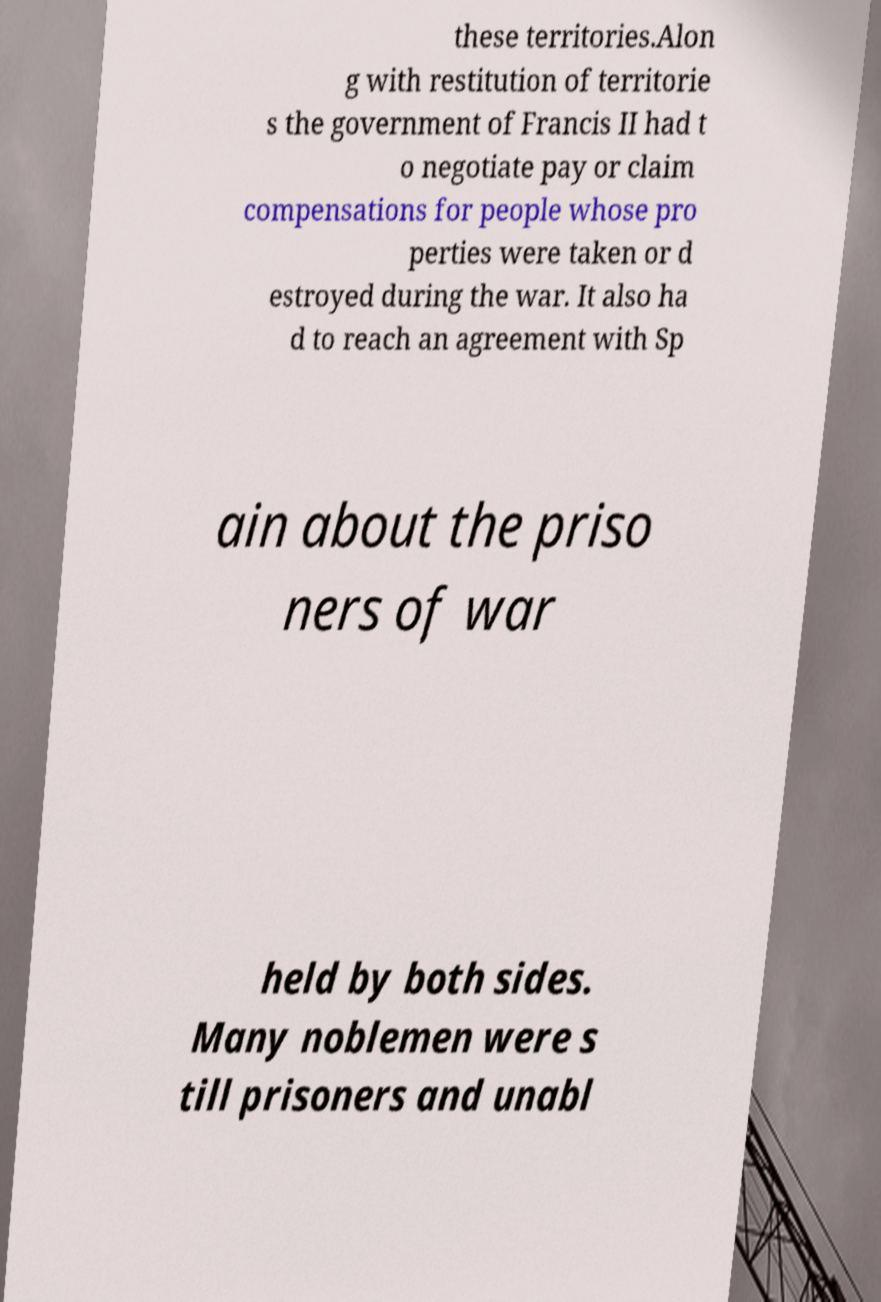Could you assist in decoding the text presented in this image and type it out clearly? these territories.Alon g with restitution of territorie s the government of Francis II had t o negotiate pay or claim compensations for people whose pro perties were taken or d estroyed during the war. It also ha d to reach an agreement with Sp ain about the priso ners of war held by both sides. Many noblemen were s till prisoners and unabl 